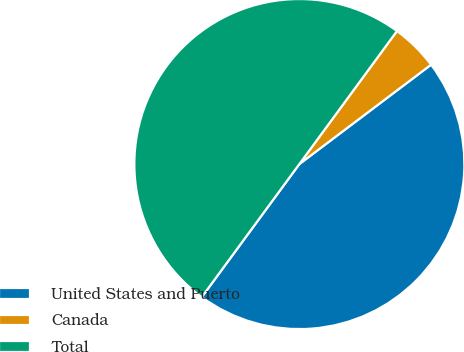<chart> <loc_0><loc_0><loc_500><loc_500><pie_chart><fcel>United States and Puerto<fcel>Canada<fcel>Total<nl><fcel>45.36%<fcel>4.64%<fcel>50.0%<nl></chart> 